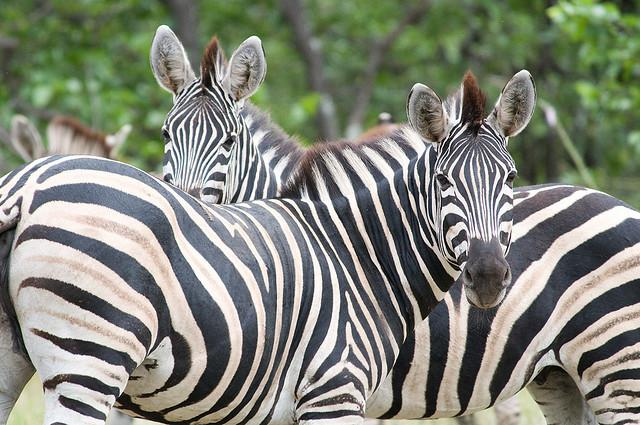How many zebras are standing in the forest with their noses pointed at the cameras?

Choices:
A) four
B) three
C) one
D) two two 